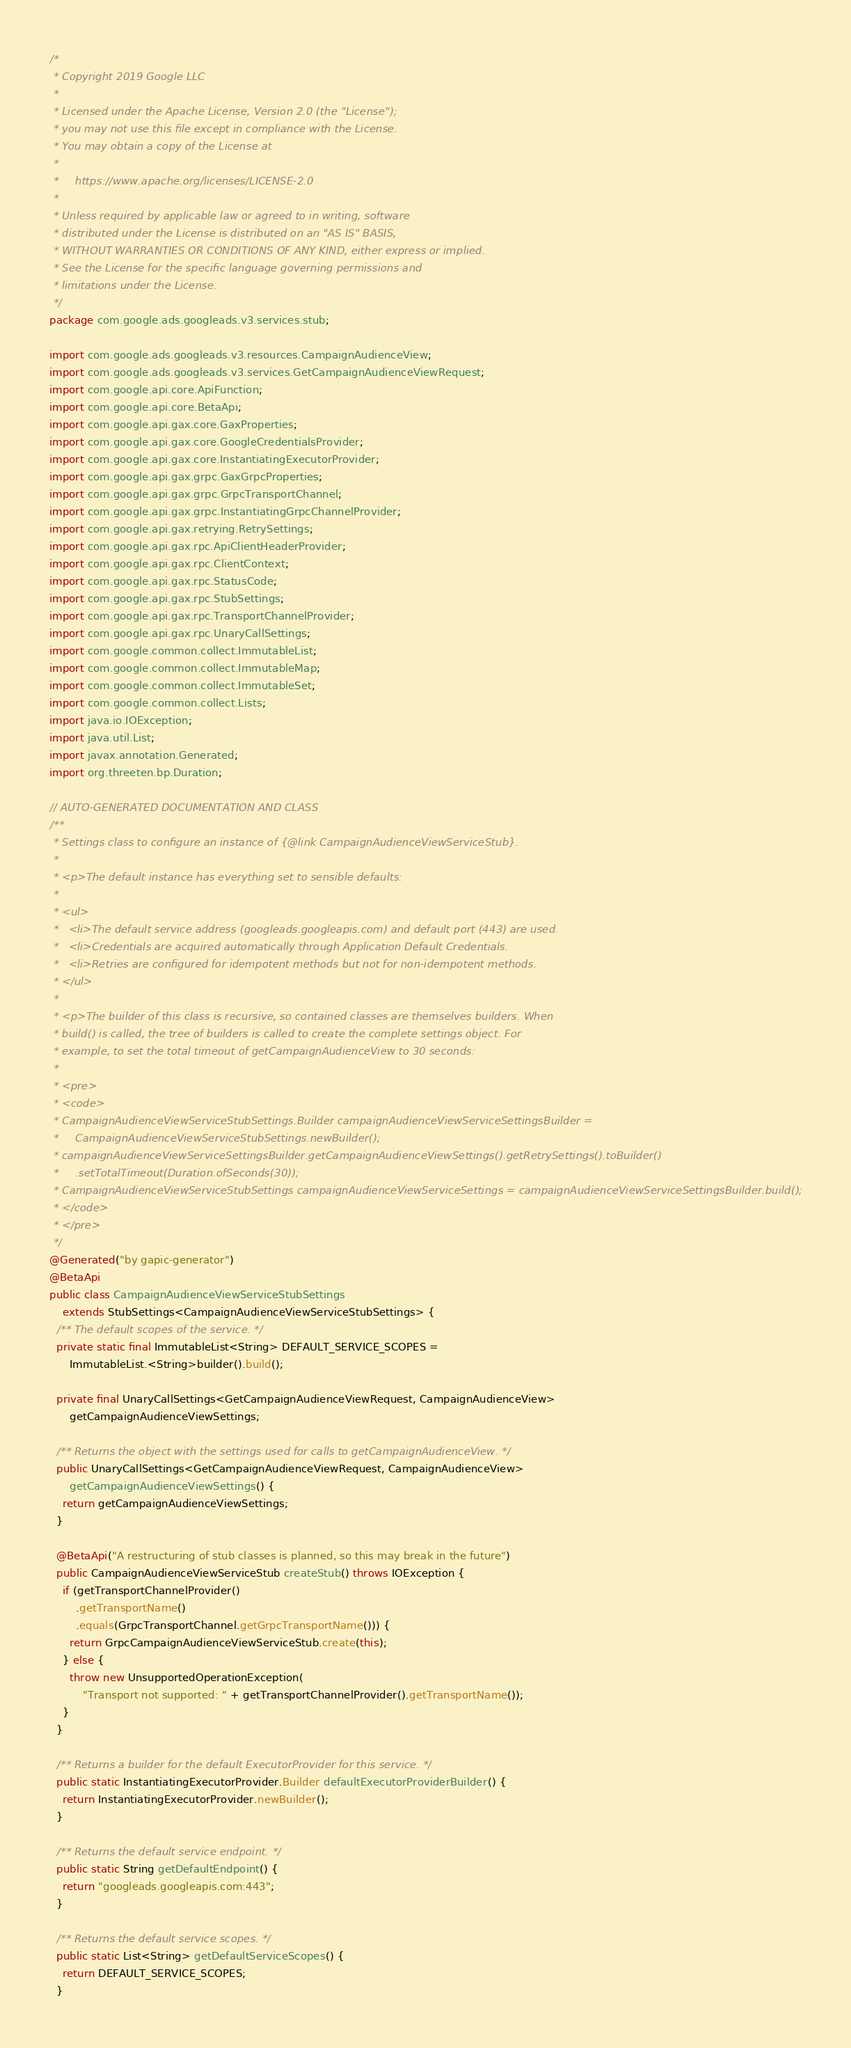<code> <loc_0><loc_0><loc_500><loc_500><_Java_>/*
 * Copyright 2019 Google LLC
 *
 * Licensed under the Apache License, Version 2.0 (the "License");
 * you may not use this file except in compliance with the License.
 * You may obtain a copy of the License at
 *
 *     https://www.apache.org/licenses/LICENSE-2.0
 *
 * Unless required by applicable law or agreed to in writing, software
 * distributed under the License is distributed on an "AS IS" BASIS,
 * WITHOUT WARRANTIES OR CONDITIONS OF ANY KIND, either express or implied.
 * See the License for the specific language governing permissions and
 * limitations under the License.
 */
package com.google.ads.googleads.v3.services.stub;

import com.google.ads.googleads.v3.resources.CampaignAudienceView;
import com.google.ads.googleads.v3.services.GetCampaignAudienceViewRequest;
import com.google.api.core.ApiFunction;
import com.google.api.core.BetaApi;
import com.google.api.gax.core.GaxProperties;
import com.google.api.gax.core.GoogleCredentialsProvider;
import com.google.api.gax.core.InstantiatingExecutorProvider;
import com.google.api.gax.grpc.GaxGrpcProperties;
import com.google.api.gax.grpc.GrpcTransportChannel;
import com.google.api.gax.grpc.InstantiatingGrpcChannelProvider;
import com.google.api.gax.retrying.RetrySettings;
import com.google.api.gax.rpc.ApiClientHeaderProvider;
import com.google.api.gax.rpc.ClientContext;
import com.google.api.gax.rpc.StatusCode;
import com.google.api.gax.rpc.StubSettings;
import com.google.api.gax.rpc.TransportChannelProvider;
import com.google.api.gax.rpc.UnaryCallSettings;
import com.google.common.collect.ImmutableList;
import com.google.common.collect.ImmutableMap;
import com.google.common.collect.ImmutableSet;
import com.google.common.collect.Lists;
import java.io.IOException;
import java.util.List;
import javax.annotation.Generated;
import org.threeten.bp.Duration;

// AUTO-GENERATED DOCUMENTATION AND CLASS
/**
 * Settings class to configure an instance of {@link CampaignAudienceViewServiceStub}.
 *
 * <p>The default instance has everything set to sensible defaults:
 *
 * <ul>
 *   <li>The default service address (googleads.googleapis.com) and default port (443) are used.
 *   <li>Credentials are acquired automatically through Application Default Credentials.
 *   <li>Retries are configured for idempotent methods but not for non-idempotent methods.
 * </ul>
 *
 * <p>The builder of this class is recursive, so contained classes are themselves builders. When
 * build() is called, the tree of builders is called to create the complete settings object. For
 * example, to set the total timeout of getCampaignAudienceView to 30 seconds:
 *
 * <pre>
 * <code>
 * CampaignAudienceViewServiceStubSettings.Builder campaignAudienceViewServiceSettingsBuilder =
 *     CampaignAudienceViewServiceStubSettings.newBuilder();
 * campaignAudienceViewServiceSettingsBuilder.getCampaignAudienceViewSettings().getRetrySettings().toBuilder()
 *     .setTotalTimeout(Duration.ofSeconds(30));
 * CampaignAudienceViewServiceStubSettings campaignAudienceViewServiceSettings = campaignAudienceViewServiceSettingsBuilder.build();
 * </code>
 * </pre>
 */
@Generated("by gapic-generator")
@BetaApi
public class CampaignAudienceViewServiceStubSettings
    extends StubSettings<CampaignAudienceViewServiceStubSettings> {
  /** The default scopes of the service. */
  private static final ImmutableList<String> DEFAULT_SERVICE_SCOPES =
      ImmutableList.<String>builder().build();

  private final UnaryCallSettings<GetCampaignAudienceViewRequest, CampaignAudienceView>
      getCampaignAudienceViewSettings;

  /** Returns the object with the settings used for calls to getCampaignAudienceView. */
  public UnaryCallSettings<GetCampaignAudienceViewRequest, CampaignAudienceView>
      getCampaignAudienceViewSettings() {
    return getCampaignAudienceViewSettings;
  }

  @BetaApi("A restructuring of stub classes is planned, so this may break in the future")
  public CampaignAudienceViewServiceStub createStub() throws IOException {
    if (getTransportChannelProvider()
        .getTransportName()
        .equals(GrpcTransportChannel.getGrpcTransportName())) {
      return GrpcCampaignAudienceViewServiceStub.create(this);
    } else {
      throw new UnsupportedOperationException(
          "Transport not supported: " + getTransportChannelProvider().getTransportName());
    }
  }

  /** Returns a builder for the default ExecutorProvider for this service. */
  public static InstantiatingExecutorProvider.Builder defaultExecutorProviderBuilder() {
    return InstantiatingExecutorProvider.newBuilder();
  }

  /** Returns the default service endpoint. */
  public static String getDefaultEndpoint() {
    return "googleads.googleapis.com:443";
  }

  /** Returns the default service scopes. */
  public static List<String> getDefaultServiceScopes() {
    return DEFAULT_SERVICE_SCOPES;
  }
</code> 